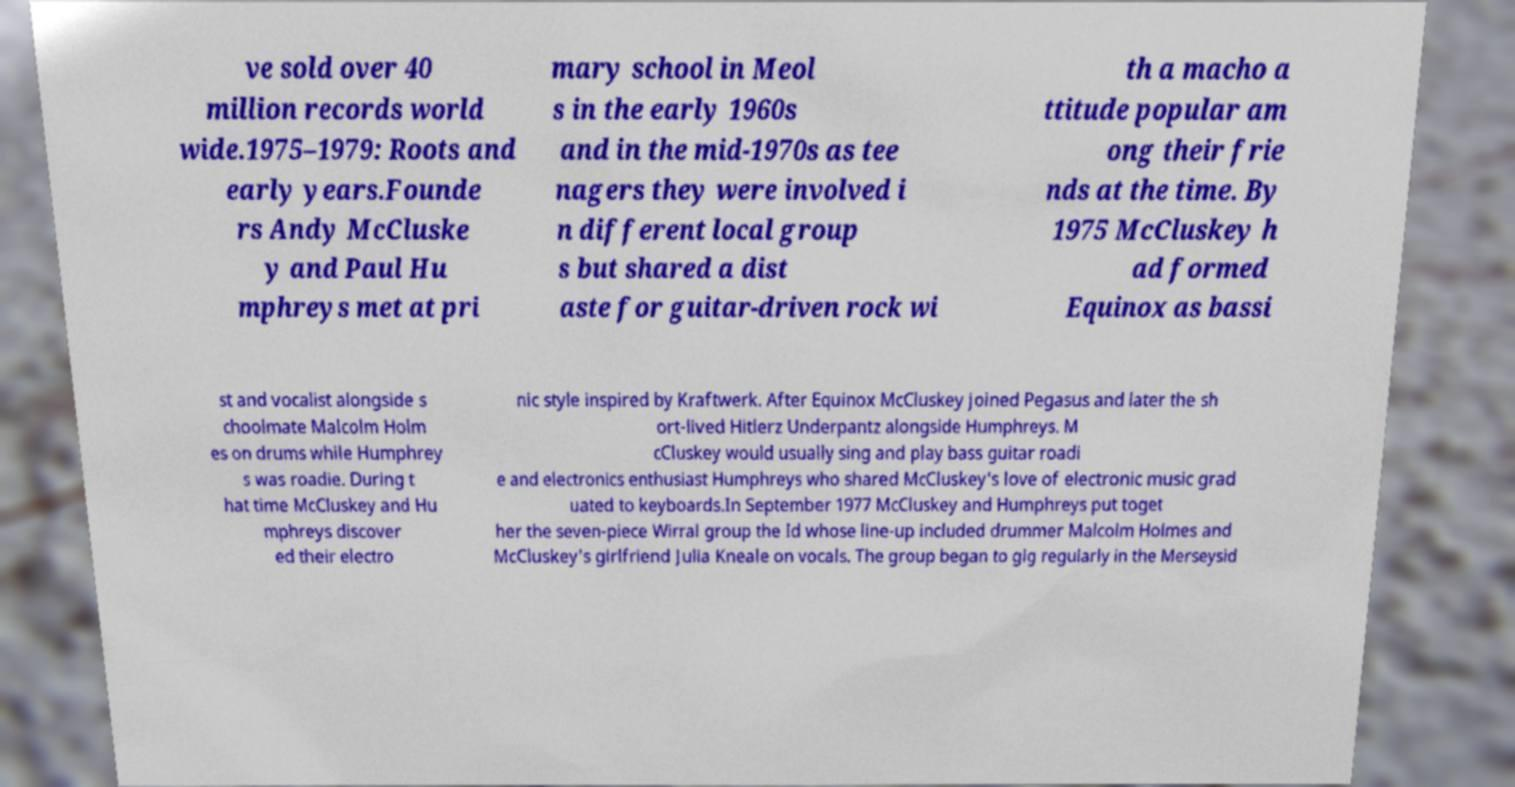I need the written content from this picture converted into text. Can you do that? ve sold over 40 million records world wide.1975–1979: Roots and early years.Founde rs Andy McCluske y and Paul Hu mphreys met at pri mary school in Meol s in the early 1960s and in the mid-1970s as tee nagers they were involved i n different local group s but shared a dist aste for guitar-driven rock wi th a macho a ttitude popular am ong their frie nds at the time. By 1975 McCluskey h ad formed Equinox as bassi st and vocalist alongside s choolmate Malcolm Holm es on drums while Humphrey s was roadie. During t hat time McCluskey and Hu mphreys discover ed their electro nic style inspired by Kraftwerk. After Equinox McCluskey joined Pegasus and later the sh ort-lived Hitlerz Underpantz alongside Humphreys. M cCluskey would usually sing and play bass guitar roadi e and electronics enthusiast Humphreys who shared McCluskey's love of electronic music grad uated to keyboards.In September 1977 McCluskey and Humphreys put toget her the seven-piece Wirral group the Id whose line-up included drummer Malcolm Holmes and McCluskey's girlfriend Julia Kneale on vocals. The group began to gig regularly in the Merseysid 